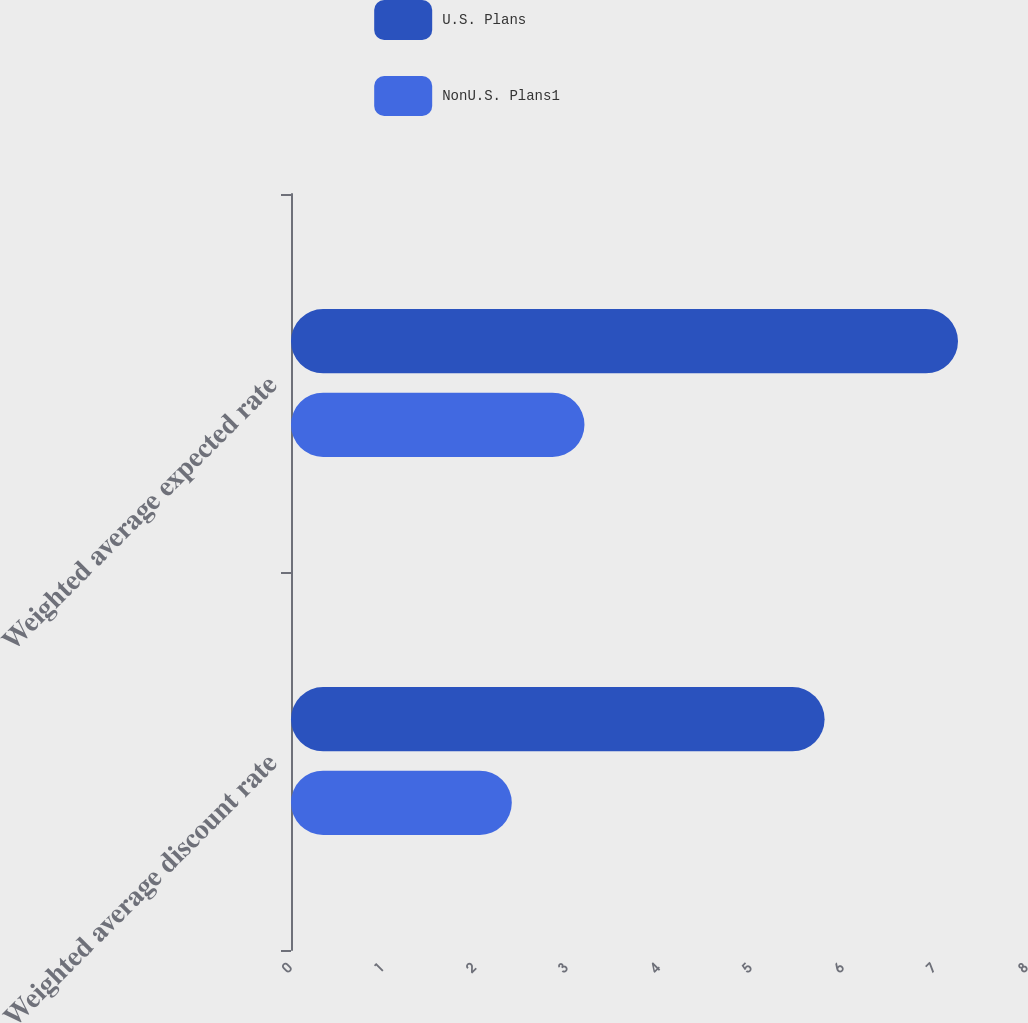<chart> <loc_0><loc_0><loc_500><loc_500><stacked_bar_chart><ecel><fcel>Weighted average discount rate<fcel>Weighted average expected rate<nl><fcel>U.S. Plans<fcel>5.8<fcel>7.25<nl><fcel>NonU.S. Plans1<fcel>2.4<fcel>3.19<nl></chart> 